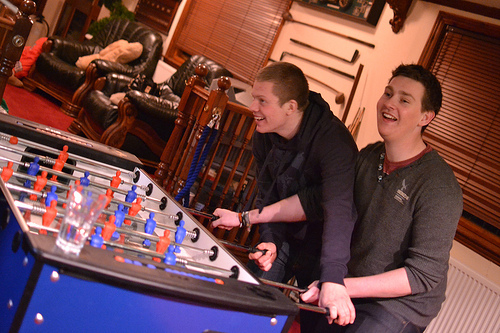<image>
Is there a boy in front of the glass? No. The boy is not in front of the glass. The spatial positioning shows a different relationship between these objects. 